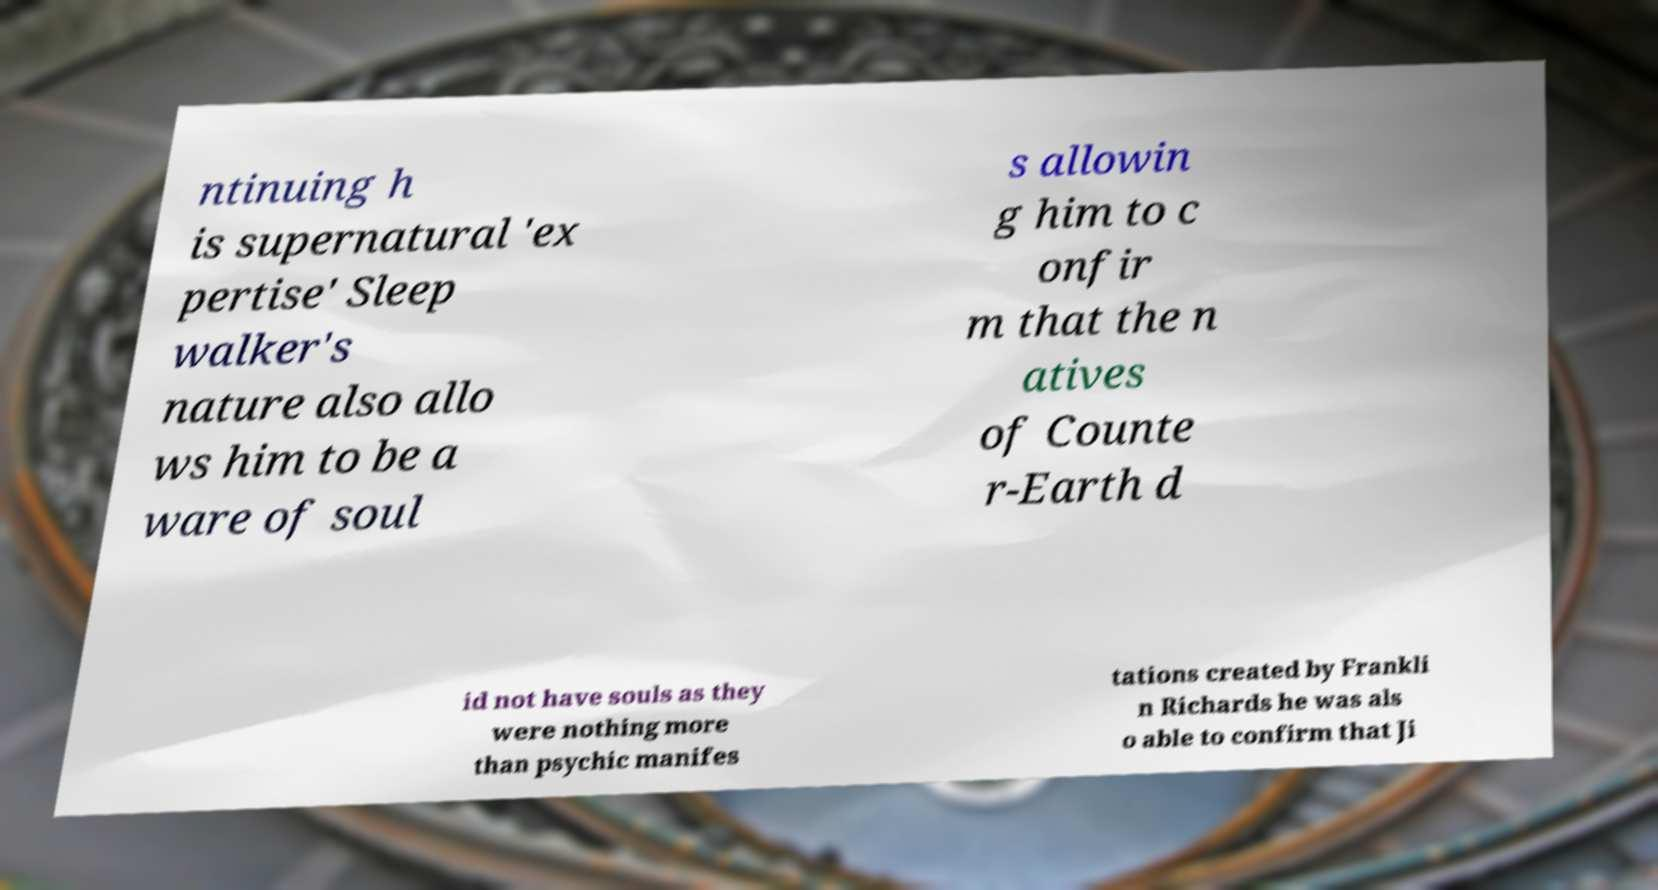Can you accurately transcribe the text from the provided image for me? ntinuing h is supernatural 'ex pertise' Sleep walker's nature also allo ws him to be a ware of soul s allowin g him to c onfir m that the n atives of Counte r-Earth d id not have souls as they were nothing more than psychic manifes tations created by Frankli n Richards he was als o able to confirm that Ji 